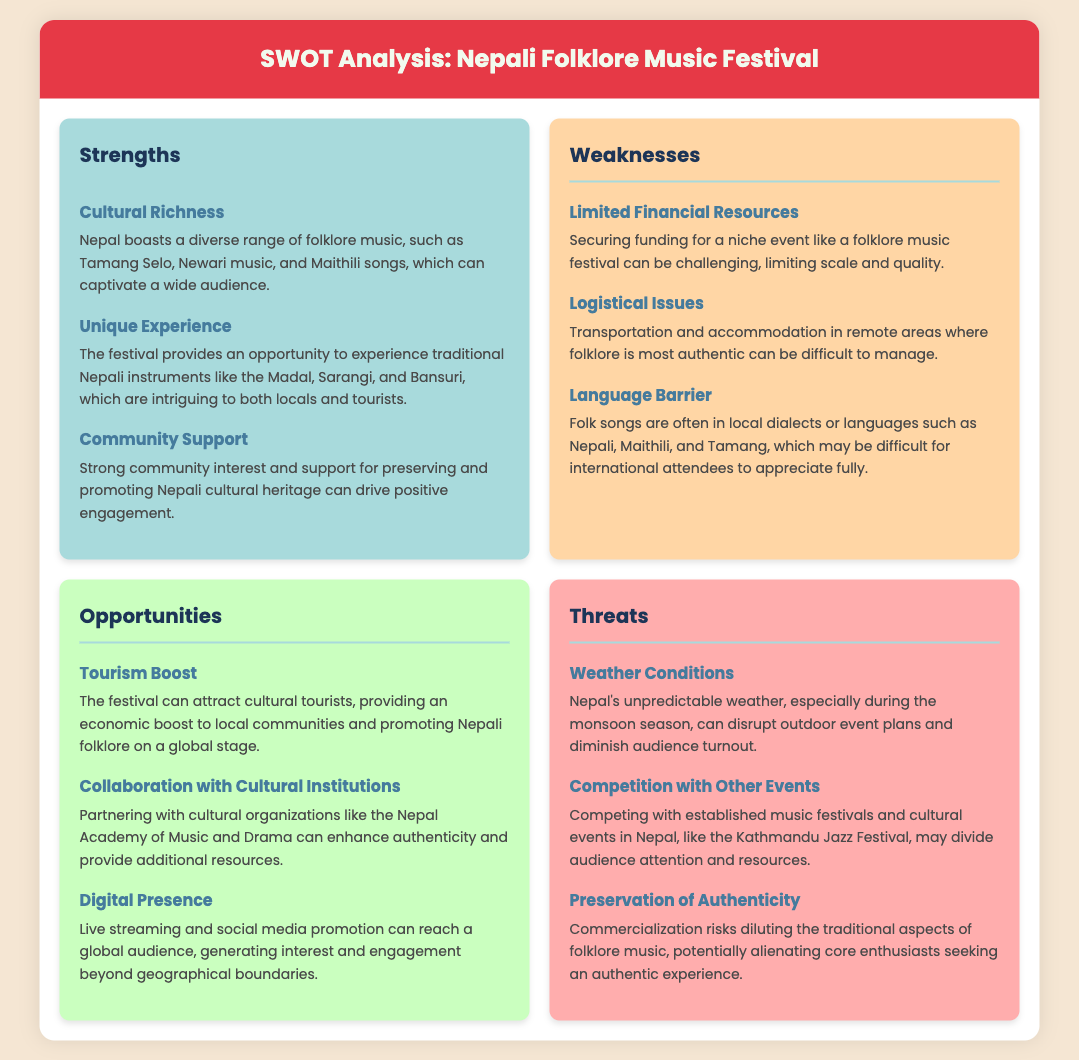What is the title of the document? The title of the document is found in the header section, which is "SWOT Analysis: Nepali Folklore Music Festival."
Answer: SWOT Analysis: Nepali Folklore Music Festival How many strengths are listed in the document? The strengths section contains three items, indicating there are three strengths listed.
Answer: 3 What is one unique experience provided by the festival? The document mentions experiencing traditional Nepali instruments, which is one of the unique experiences provided by the festival.
Answer: Traditional Nepali instruments What is a major weakness related to financial aspects? The weakness section states "Limited Financial Resources," highlighting the financial challenges of organizing the festival.
Answer: Limited Financial Resources Which opportunity is related to enhancing authenticity? The opportunity to collaborate with cultural institutions, specifically mentioned as "partnering with cultural organizations," enhances authenticity.
Answer: Collaboration with Cultural Institutions What threat is associated with the weather? The document discusses "Weather Conditions" as a threat that can disrupt the event plans.
Answer: Weather Conditions What is a potential benefit to local communities from the festival? The document mentions that the festival can provide an economic boost to local communities as a benefit.
Answer: Economic boost What competition is highlighted as a threat? The document lists "Competition with Other Events," pointing out the challenge with established festivals.
Answer: Competition with Other Events What type of music is associated with Nepali culture as a strength? Folk music referring to diverse genres is considered a strength of Nepali culture in the document.
Answer: Folklore music 